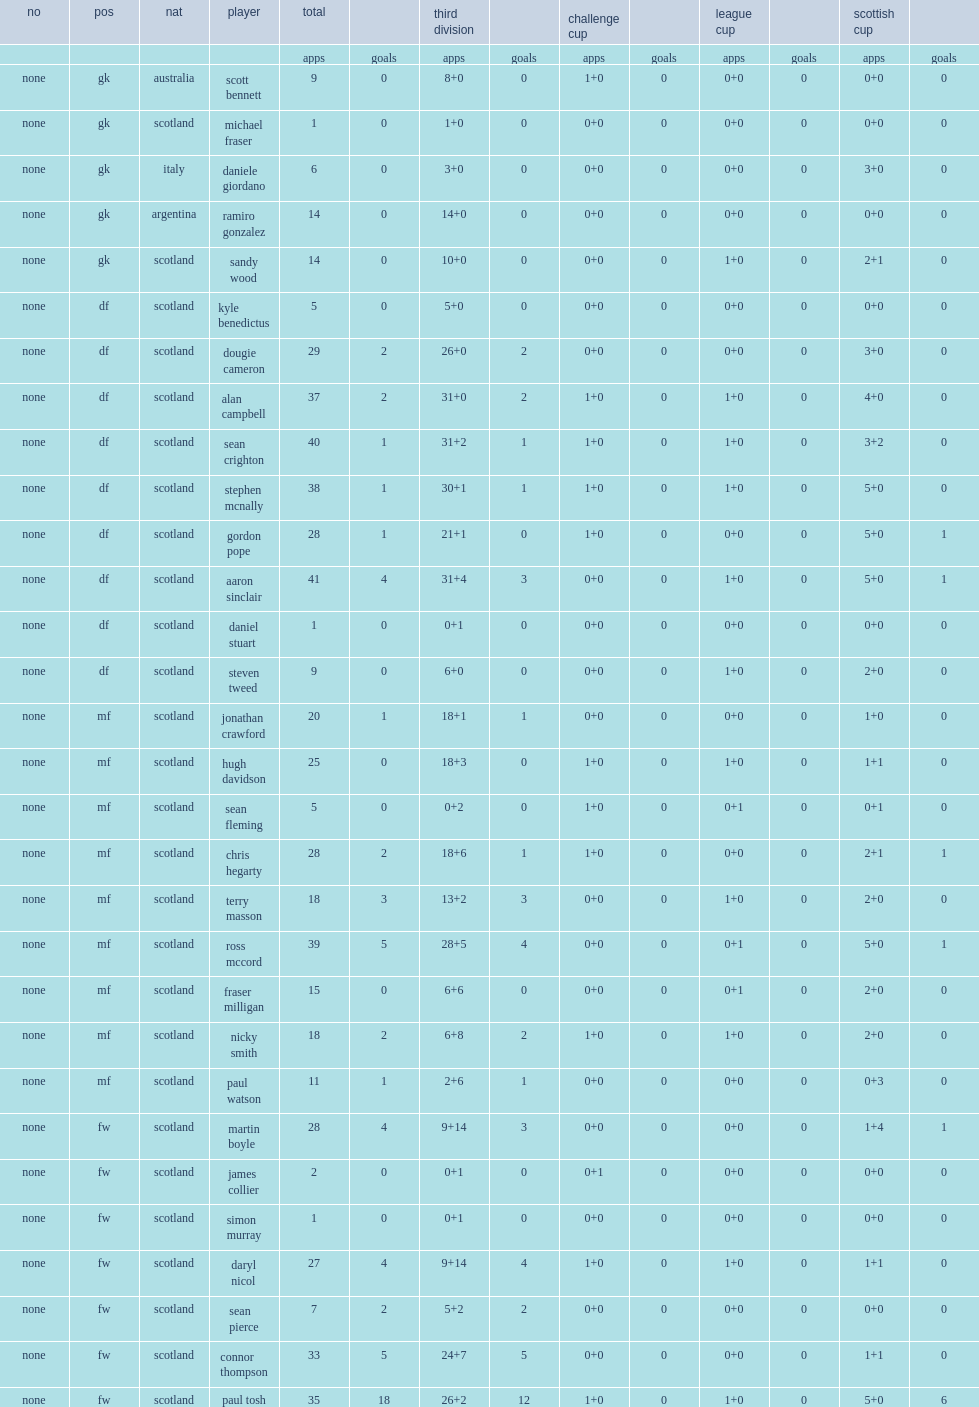What cups did montrose participate in? Challenge cup league cup scottish cup. 